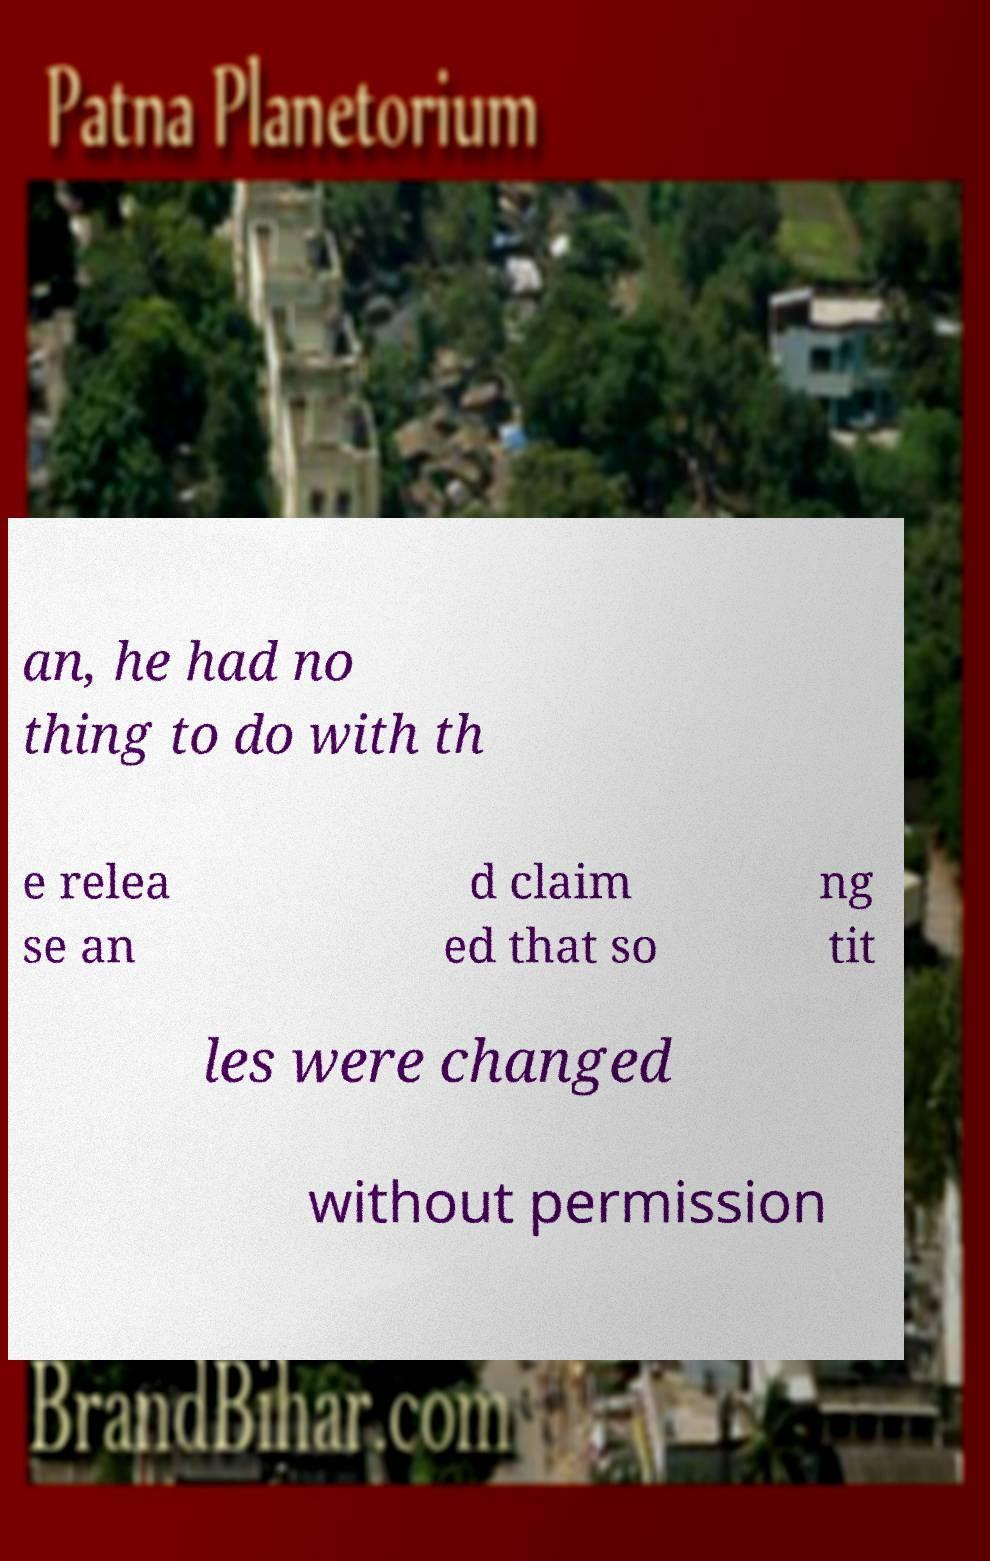There's text embedded in this image that I need extracted. Can you transcribe it verbatim? an, he had no thing to do with th e relea se an d claim ed that so ng tit les were changed without permission 